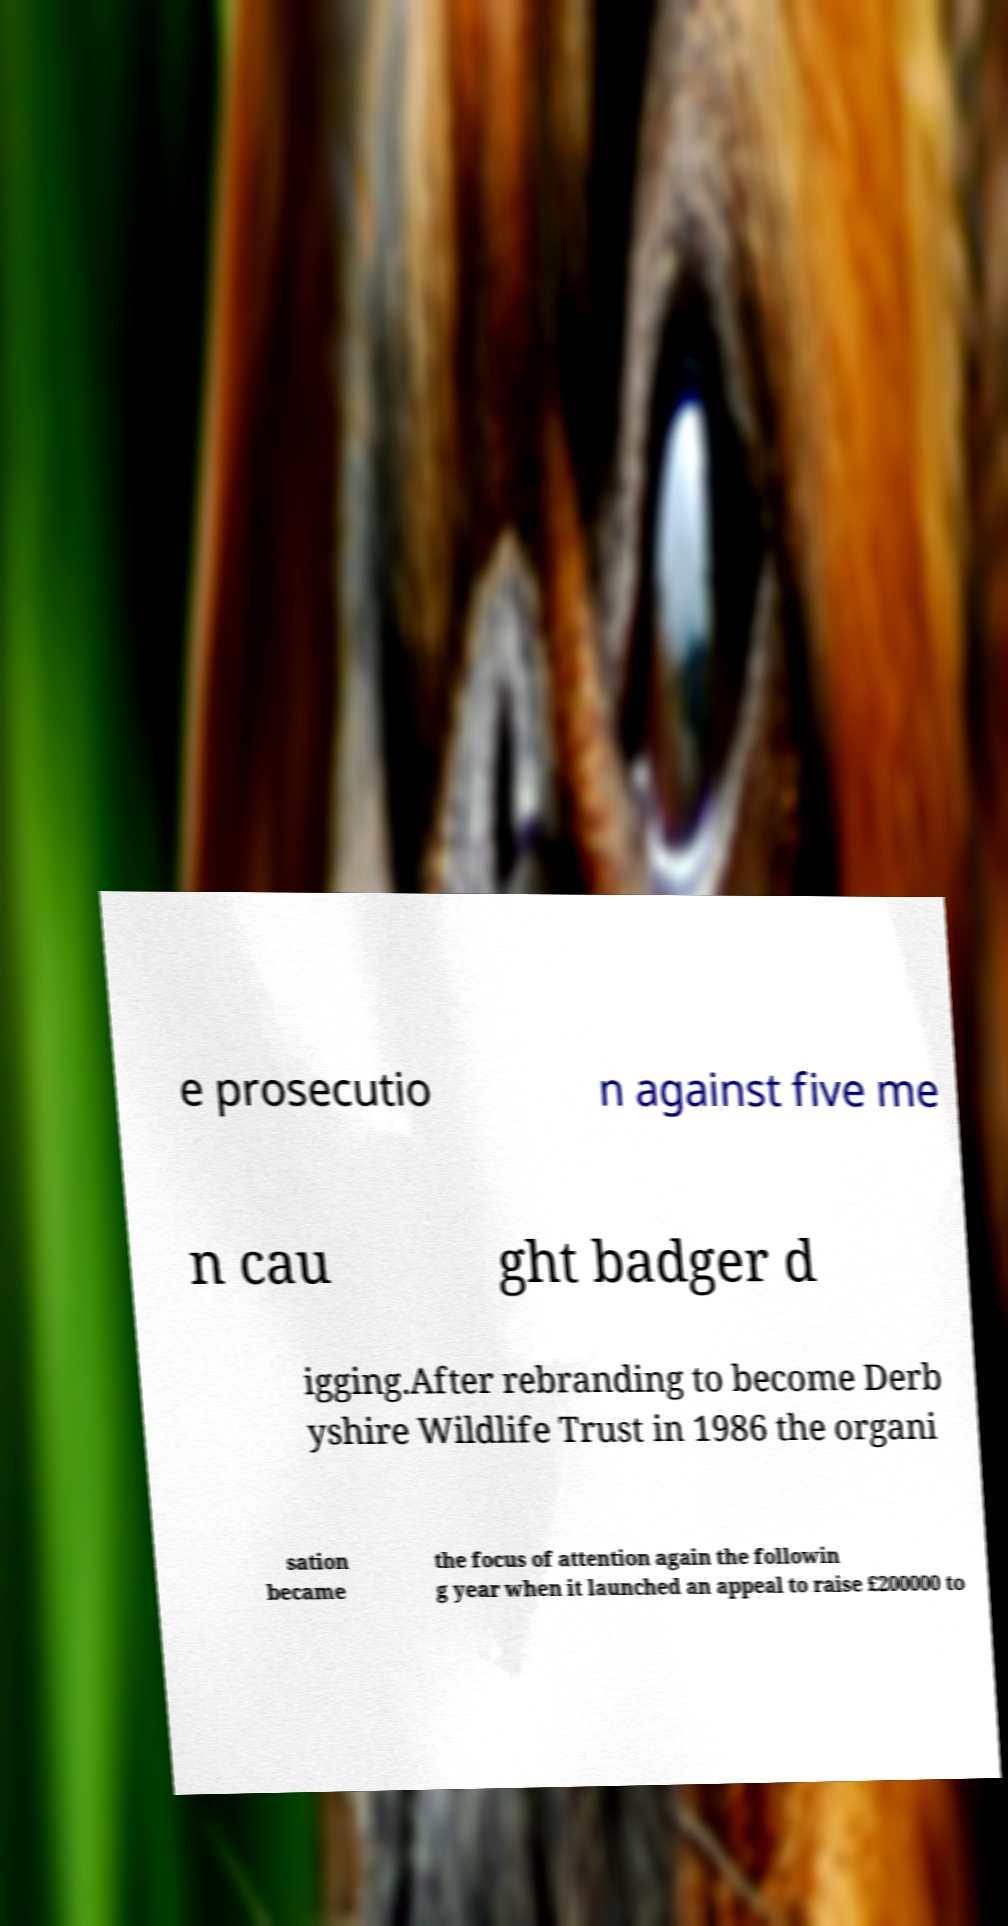Please read and relay the text visible in this image. What does it say? e prosecutio n against five me n cau ght badger d igging.After rebranding to become Derb yshire Wildlife Trust in 1986 the organi sation became the focus of attention again the followin g year when it launched an appeal to raise £200000 to 